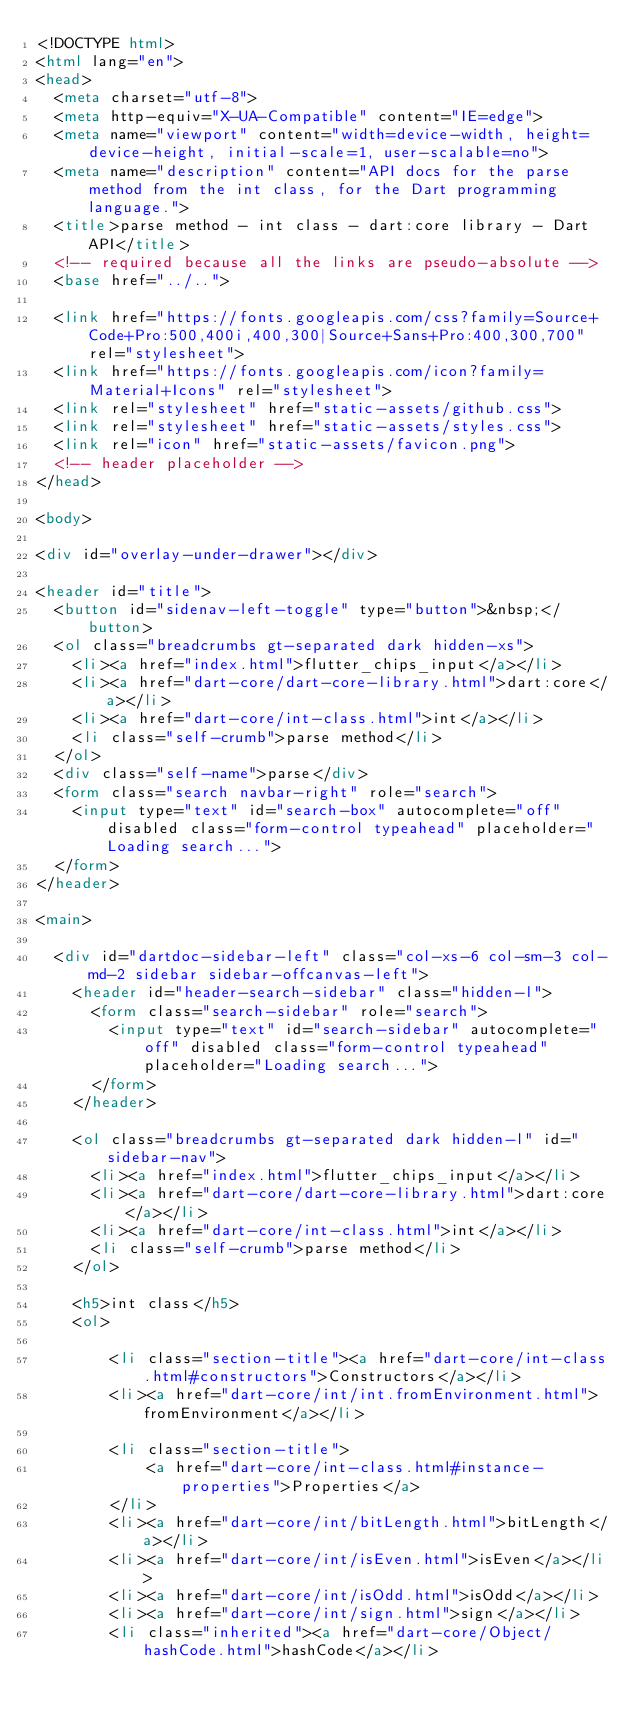Convert code to text. <code><loc_0><loc_0><loc_500><loc_500><_HTML_><!DOCTYPE html>
<html lang="en">
<head>
  <meta charset="utf-8">
  <meta http-equiv="X-UA-Compatible" content="IE=edge">
  <meta name="viewport" content="width=device-width, height=device-height, initial-scale=1, user-scalable=no">
  <meta name="description" content="API docs for the parse method from the int class, for the Dart programming language.">
  <title>parse method - int class - dart:core library - Dart API</title>
  <!-- required because all the links are pseudo-absolute -->
  <base href="../..">

  <link href="https://fonts.googleapis.com/css?family=Source+Code+Pro:500,400i,400,300|Source+Sans+Pro:400,300,700" rel="stylesheet">
  <link href="https://fonts.googleapis.com/icon?family=Material+Icons" rel="stylesheet">
  <link rel="stylesheet" href="static-assets/github.css">
  <link rel="stylesheet" href="static-assets/styles.css">
  <link rel="icon" href="static-assets/favicon.png">
  <!-- header placeholder -->
</head>

<body>

<div id="overlay-under-drawer"></div>

<header id="title">
  <button id="sidenav-left-toggle" type="button">&nbsp;</button>
  <ol class="breadcrumbs gt-separated dark hidden-xs">
    <li><a href="index.html">flutter_chips_input</a></li>
    <li><a href="dart-core/dart-core-library.html">dart:core</a></li>
    <li><a href="dart-core/int-class.html">int</a></li>
    <li class="self-crumb">parse method</li>
  </ol>
  <div class="self-name">parse</div>
  <form class="search navbar-right" role="search">
    <input type="text" id="search-box" autocomplete="off" disabled class="form-control typeahead" placeholder="Loading search...">
  </form>
</header>

<main>

  <div id="dartdoc-sidebar-left" class="col-xs-6 col-sm-3 col-md-2 sidebar sidebar-offcanvas-left">
    <header id="header-search-sidebar" class="hidden-l">
      <form class="search-sidebar" role="search">
        <input type="text" id="search-sidebar" autocomplete="off" disabled class="form-control typeahead" placeholder="Loading search...">
      </form>
    </header>
    
    <ol class="breadcrumbs gt-separated dark hidden-l" id="sidebar-nav">
      <li><a href="index.html">flutter_chips_input</a></li>
      <li><a href="dart-core/dart-core-library.html">dart:core</a></li>
      <li><a href="dart-core/int-class.html">int</a></li>
      <li class="self-crumb">parse method</li>
    </ol>
    
    <h5>int class</h5>
    <ol>
    
        <li class="section-title"><a href="dart-core/int-class.html#constructors">Constructors</a></li>
        <li><a href="dart-core/int/int.fromEnvironment.html">fromEnvironment</a></li>
    
        <li class="section-title">
            <a href="dart-core/int-class.html#instance-properties">Properties</a>
        </li>
        <li><a href="dart-core/int/bitLength.html">bitLength</a></li>
        <li><a href="dart-core/int/isEven.html">isEven</a></li>
        <li><a href="dart-core/int/isOdd.html">isOdd</a></li>
        <li><a href="dart-core/int/sign.html">sign</a></li>
        <li class="inherited"><a href="dart-core/Object/hashCode.html">hashCode</a></li></code> 